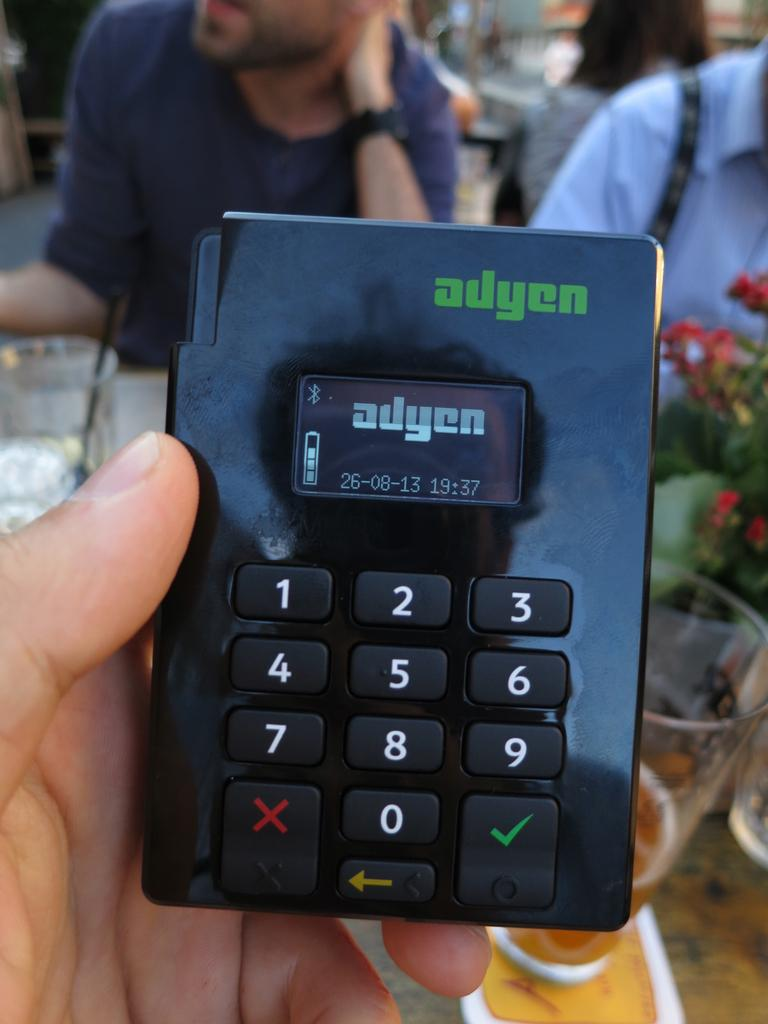<image>
Relay a brief, clear account of the picture shown. A device with the brand ayden has a key pad a small screen. 